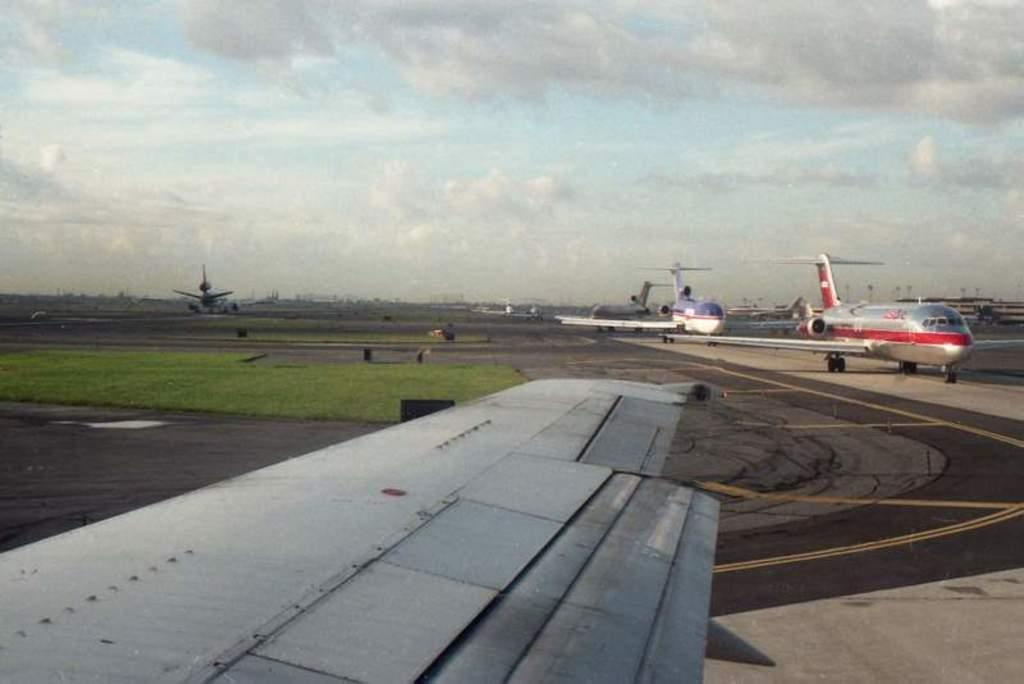What is the main subject of the image? The main subject of the image is airplanes. What type of surface can be seen in the image? There is a grass surface in the image. What action is being performed by one of the airplanes in the image? There is a plane taking off in the background of the image. Where is the queen sitting on a bean in the image? There is no queen or bean present in the image; it features airplanes and a grass surface. 